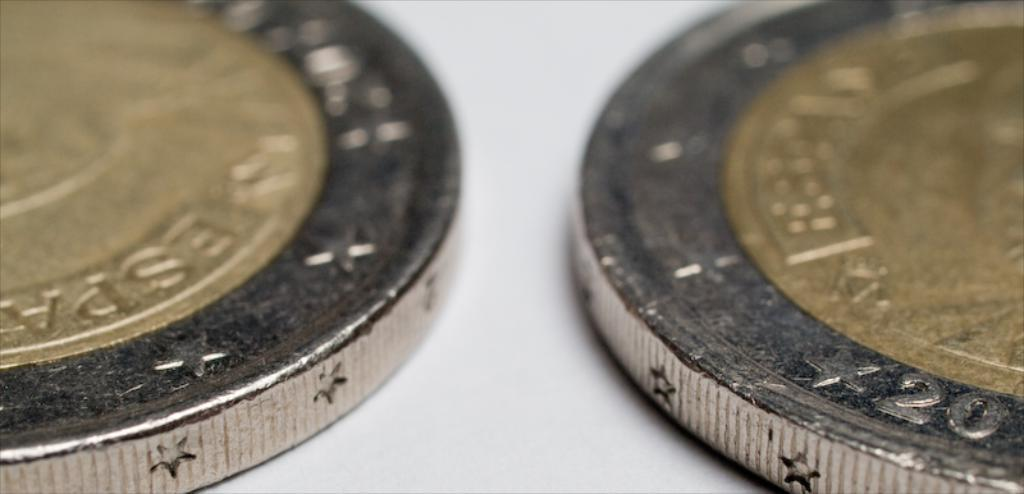Provide a one-sentence caption for the provided image. Twenty and several stars are etched into the edge of this coin. 